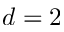Convert formula to latex. <formula><loc_0><loc_0><loc_500><loc_500>d = 2</formula> 